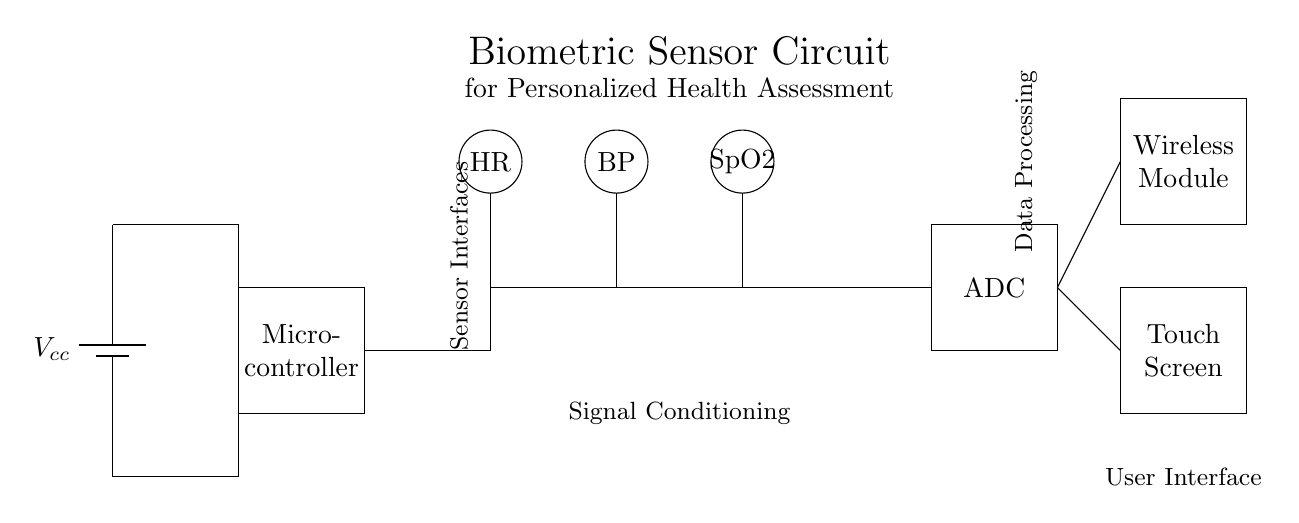What is the main power supply in this circuit? The main power supply is represented by the battery symbol, which is labeled as Vcc. This provides the necessary voltage for the entire circuit to operate.
Answer: Vcc How many biometric sensors are present? There are three biometric sensors in the circuit, indicated by the labels HR (Heart Rate), BP (Blood Pressure), and SpO2 (Blood Oxygen Saturation). Each sensor is represented by a circle with its abbreviation.
Answer: Three What component processes the signals from the sensors? The signals from the sensors are processed by operational amplifiers, which are depicted as op amp symbols in the circuit diagram connecting the sensors and the ADC (Analog to Digital Converter).
Answer: Operational amplifiers What is the output interface for user interaction in the circuit? The user interface for interaction is represented as a touch screen, shown as a rectangle labeled "Touch Screen," allowing users to view and navigate the health assessment information.
Answer: Touch Screen Which component converts analog signals to digital signals? The component that converts analog signals to digital is the ADC, labeled simply as "ADC" in a rectangle. This device is crucial for transforming the signals received from the amplifiers into a digital form for processing.
Answer: ADC How are the sensor interfaces connected to the microcontroller? The sensor interfaces are connected to the microcontroller through direct connections depicted by straight lines, showing that the microcontroller receives processed signals directly from the sensors via the operational amplifiers.
Answer: Direct connections What is the purpose of the wireless module in this circuit? The wireless module is used for transmitting the collected health data wirelessly, enabling remote access and monitoring of the individual's health metrics. This is crucial for personalized health assessment applications.
Answer: Data transmission 